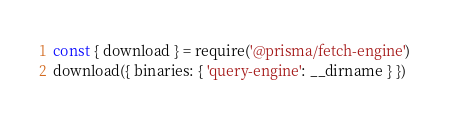<code> <loc_0><loc_0><loc_500><loc_500><_JavaScript_>const { download } = require('@prisma/fetch-engine')
download({ binaries: { 'query-engine': __dirname } })
</code> 